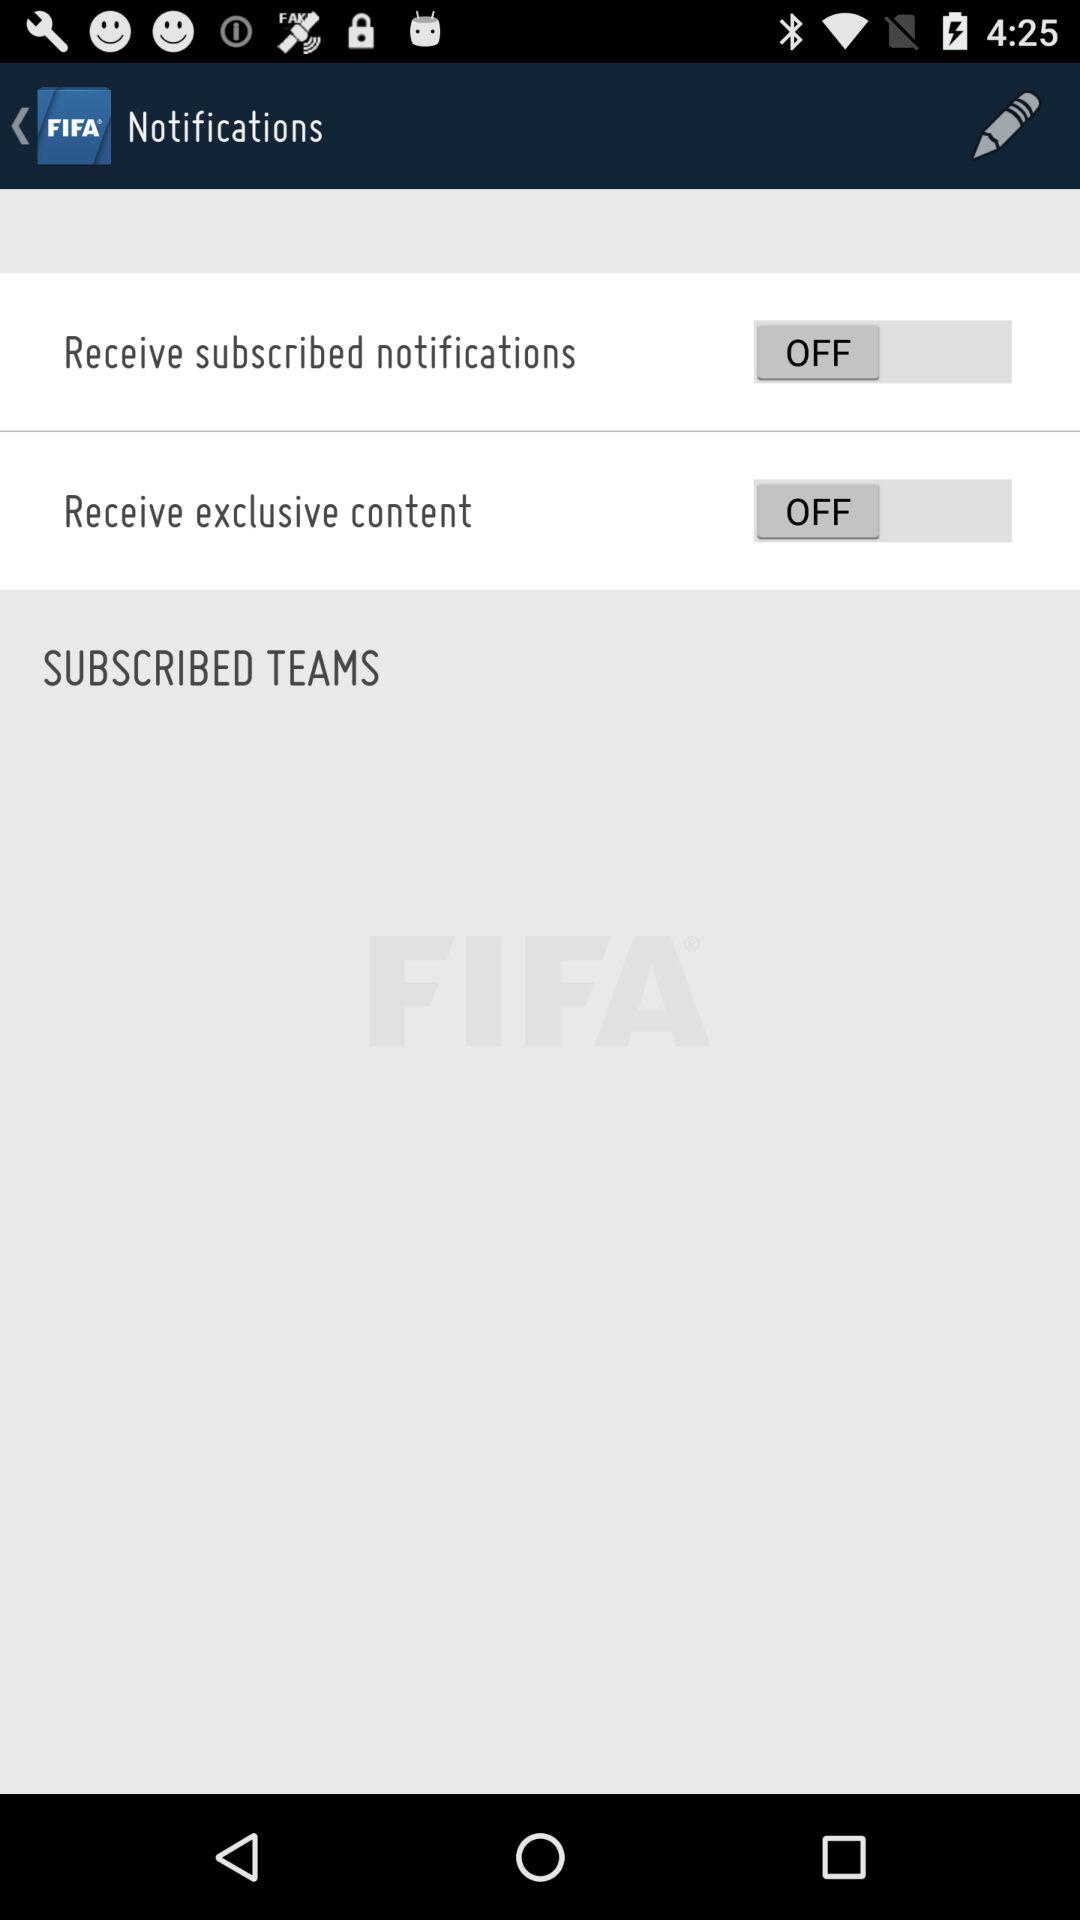What is the status of "Receive exclusive content"? The status of "Receive exclusive content" is "off". 